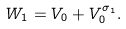<formula> <loc_0><loc_0><loc_500><loc_500>W _ { 1 } = V _ { 0 } + V _ { 0 } ^ { \sigma _ { 1 } } .</formula> 